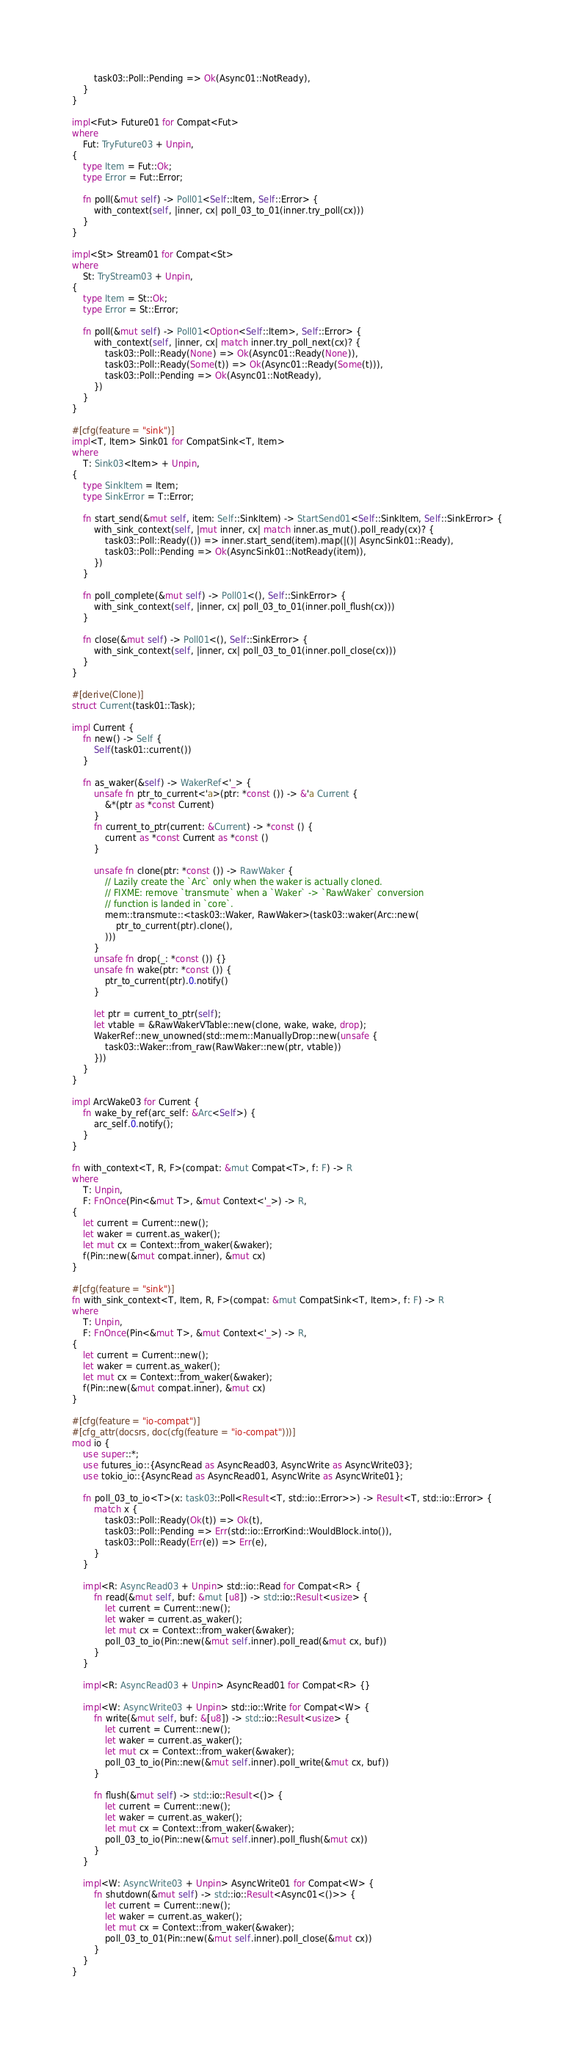Convert code to text. <code><loc_0><loc_0><loc_500><loc_500><_Rust_>        task03::Poll::Pending => Ok(Async01::NotReady),
    }
}

impl<Fut> Future01 for Compat<Fut>
where
    Fut: TryFuture03 + Unpin,
{
    type Item = Fut::Ok;
    type Error = Fut::Error;

    fn poll(&mut self) -> Poll01<Self::Item, Self::Error> {
        with_context(self, |inner, cx| poll_03_to_01(inner.try_poll(cx)))
    }
}

impl<St> Stream01 for Compat<St>
where
    St: TryStream03 + Unpin,
{
    type Item = St::Ok;
    type Error = St::Error;

    fn poll(&mut self) -> Poll01<Option<Self::Item>, Self::Error> {
        with_context(self, |inner, cx| match inner.try_poll_next(cx)? {
            task03::Poll::Ready(None) => Ok(Async01::Ready(None)),
            task03::Poll::Ready(Some(t)) => Ok(Async01::Ready(Some(t))),
            task03::Poll::Pending => Ok(Async01::NotReady),
        })
    }
}

#[cfg(feature = "sink")]
impl<T, Item> Sink01 for CompatSink<T, Item>
where
    T: Sink03<Item> + Unpin,
{
    type SinkItem = Item;
    type SinkError = T::Error;

    fn start_send(&mut self, item: Self::SinkItem) -> StartSend01<Self::SinkItem, Self::SinkError> {
        with_sink_context(self, |mut inner, cx| match inner.as_mut().poll_ready(cx)? {
            task03::Poll::Ready(()) => inner.start_send(item).map(|()| AsyncSink01::Ready),
            task03::Poll::Pending => Ok(AsyncSink01::NotReady(item)),
        })
    }

    fn poll_complete(&mut self) -> Poll01<(), Self::SinkError> {
        with_sink_context(self, |inner, cx| poll_03_to_01(inner.poll_flush(cx)))
    }

    fn close(&mut self) -> Poll01<(), Self::SinkError> {
        with_sink_context(self, |inner, cx| poll_03_to_01(inner.poll_close(cx)))
    }
}

#[derive(Clone)]
struct Current(task01::Task);

impl Current {
    fn new() -> Self {
        Self(task01::current())
    }

    fn as_waker(&self) -> WakerRef<'_> {
        unsafe fn ptr_to_current<'a>(ptr: *const ()) -> &'a Current {
            &*(ptr as *const Current)
        }
        fn current_to_ptr(current: &Current) -> *const () {
            current as *const Current as *const ()
        }

        unsafe fn clone(ptr: *const ()) -> RawWaker {
            // Lazily create the `Arc` only when the waker is actually cloned.
            // FIXME: remove `transmute` when a `Waker` -> `RawWaker` conversion
            // function is landed in `core`.
            mem::transmute::<task03::Waker, RawWaker>(task03::waker(Arc::new(
                ptr_to_current(ptr).clone(),
            )))
        }
        unsafe fn drop(_: *const ()) {}
        unsafe fn wake(ptr: *const ()) {
            ptr_to_current(ptr).0.notify()
        }

        let ptr = current_to_ptr(self);
        let vtable = &RawWakerVTable::new(clone, wake, wake, drop);
        WakerRef::new_unowned(std::mem::ManuallyDrop::new(unsafe {
            task03::Waker::from_raw(RawWaker::new(ptr, vtable))
        }))
    }
}

impl ArcWake03 for Current {
    fn wake_by_ref(arc_self: &Arc<Self>) {
        arc_self.0.notify();
    }
}

fn with_context<T, R, F>(compat: &mut Compat<T>, f: F) -> R
where
    T: Unpin,
    F: FnOnce(Pin<&mut T>, &mut Context<'_>) -> R,
{
    let current = Current::new();
    let waker = current.as_waker();
    let mut cx = Context::from_waker(&waker);
    f(Pin::new(&mut compat.inner), &mut cx)
}

#[cfg(feature = "sink")]
fn with_sink_context<T, Item, R, F>(compat: &mut CompatSink<T, Item>, f: F) -> R
where
    T: Unpin,
    F: FnOnce(Pin<&mut T>, &mut Context<'_>) -> R,
{
    let current = Current::new();
    let waker = current.as_waker();
    let mut cx = Context::from_waker(&waker);
    f(Pin::new(&mut compat.inner), &mut cx)
}

#[cfg(feature = "io-compat")]
#[cfg_attr(docsrs, doc(cfg(feature = "io-compat")))]
mod io {
    use super::*;
    use futures_io::{AsyncRead as AsyncRead03, AsyncWrite as AsyncWrite03};
    use tokio_io::{AsyncRead as AsyncRead01, AsyncWrite as AsyncWrite01};

    fn poll_03_to_io<T>(x: task03::Poll<Result<T, std::io::Error>>) -> Result<T, std::io::Error> {
        match x {
            task03::Poll::Ready(Ok(t)) => Ok(t),
            task03::Poll::Pending => Err(std::io::ErrorKind::WouldBlock.into()),
            task03::Poll::Ready(Err(e)) => Err(e),
        }
    }

    impl<R: AsyncRead03 + Unpin> std::io::Read for Compat<R> {
        fn read(&mut self, buf: &mut [u8]) -> std::io::Result<usize> {
            let current = Current::new();
            let waker = current.as_waker();
            let mut cx = Context::from_waker(&waker);
            poll_03_to_io(Pin::new(&mut self.inner).poll_read(&mut cx, buf))
        }
    }

    impl<R: AsyncRead03 + Unpin> AsyncRead01 for Compat<R> {}

    impl<W: AsyncWrite03 + Unpin> std::io::Write for Compat<W> {
        fn write(&mut self, buf: &[u8]) -> std::io::Result<usize> {
            let current = Current::new();
            let waker = current.as_waker();
            let mut cx = Context::from_waker(&waker);
            poll_03_to_io(Pin::new(&mut self.inner).poll_write(&mut cx, buf))
        }

        fn flush(&mut self) -> std::io::Result<()> {
            let current = Current::new();
            let waker = current.as_waker();
            let mut cx = Context::from_waker(&waker);
            poll_03_to_io(Pin::new(&mut self.inner).poll_flush(&mut cx))
        }
    }

    impl<W: AsyncWrite03 + Unpin> AsyncWrite01 for Compat<W> {
        fn shutdown(&mut self) -> std::io::Result<Async01<()>> {
            let current = Current::new();
            let waker = current.as_waker();
            let mut cx = Context::from_waker(&waker);
            poll_03_to_01(Pin::new(&mut self.inner).poll_close(&mut cx))
        }
    }
}
</code> 